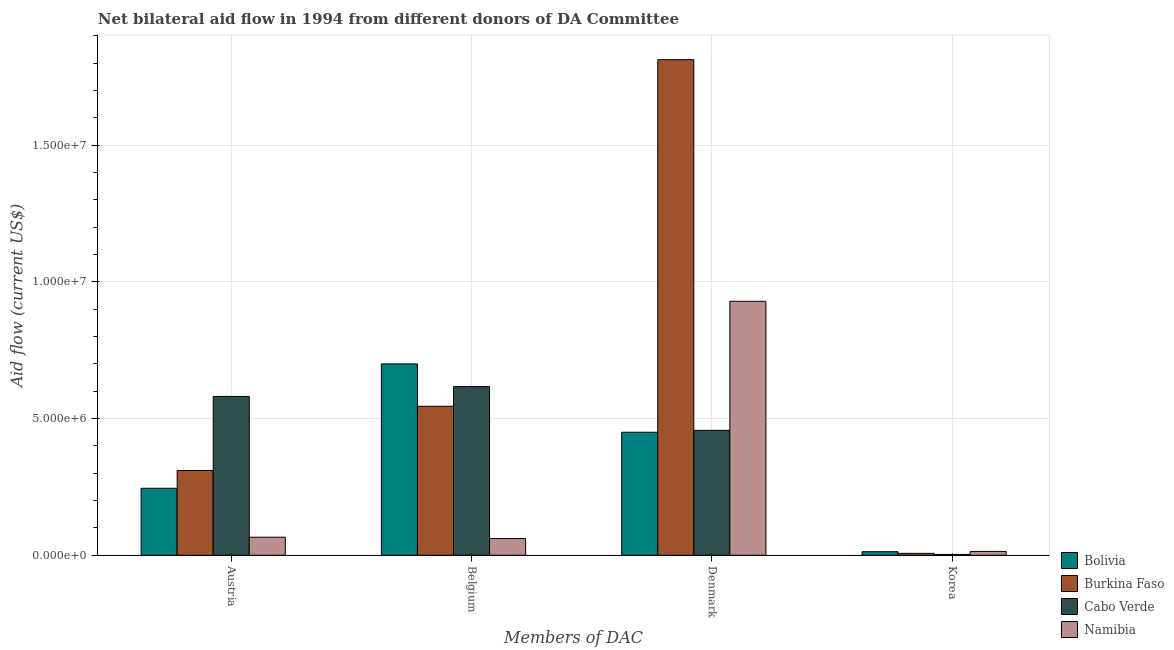How many groups of bars are there?
Provide a short and direct response. 4. Are the number of bars per tick equal to the number of legend labels?
Provide a short and direct response. Yes. How many bars are there on the 2nd tick from the left?
Your answer should be very brief. 4. How many bars are there on the 2nd tick from the right?
Offer a very short reply. 4. What is the label of the 2nd group of bars from the left?
Your answer should be very brief. Belgium. What is the amount of aid given by denmark in Bolivia?
Make the answer very short. 4.50e+06. Across all countries, what is the maximum amount of aid given by denmark?
Ensure brevity in your answer.  1.81e+07. Across all countries, what is the minimum amount of aid given by austria?
Offer a very short reply. 6.60e+05. In which country was the amount of aid given by korea maximum?
Provide a short and direct response. Namibia. In which country was the amount of aid given by austria minimum?
Offer a terse response. Namibia. What is the total amount of aid given by denmark in the graph?
Your answer should be compact. 3.65e+07. What is the difference between the amount of aid given by belgium in Bolivia and that in Burkina Faso?
Make the answer very short. 1.55e+06. What is the difference between the amount of aid given by korea in Cabo Verde and the amount of aid given by austria in Burkina Faso?
Your response must be concise. -3.07e+06. What is the average amount of aid given by belgium per country?
Your answer should be compact. 4.81e+06. What is the difference between the amount of aid given by austria and amount of aid given by korea in Burkina Faso?
Your answer should be very brief. 3.03e+06. In how many countries, is the amount of aid given by belgium greater than 8000000 US$?
Ensure brevity in your answer.  0. What is the ratio of the amount of aid given by denmark in Namibia to that in Bolivia?
Your answer should be compact. 2.06. What is the difference between the highest and the lowest amount of aid given by denmark?
Ensure brevity in your answer.  1.36e+07. In how many countries, is the amount of aid given by austria greater than the average amount of aid given by austria taken over all countries?
Your response must be concise. 2. Is the sum of the amount of aid given by korea in Burkina Faso and Cabo Verde greater than the maximum amount of aid given by denmark across all countries?
Give a very brief answer. No. What does the 2nd bar from the left in Denmark represents?
Provide a short and direct response. Burkina Faso. What does the 1st bar from the right in Austria represents?
Your answer should be compact. Namibia. How many bars are there?
Offer a very short reply. 16. What is the difference between two consecutive major ticks on the Y-axis?
Ensure brevity in your answer.  5.00e+06. Are the values on the major ticks of Y-axis written in scientific E-notation?
Give a very brief answer. Yes. Does the graph contain any zero values?
Offer a terse response. No. Where does the legend appear in the graph?
Ensure brevity in your answer.  Bottom right. How many legend labels are there?
Provide a short and direct response. 4. How are the legend labels stacked?
Your response must be concise. Vertical. What is the title of the graph?
Your response must be concise. Net bilateral aid flow in 1994 from different donors of DA Committee. Does "Turkmenistan" appear as one of the legend labels in the graph?
Make the answer very short. No. What is the label or title of the X-axis?
Provide a succinct answer. Members of DAC. What is the Aid flow (current US$) of Bolivia in Austria?
Provide a short and direct response. 2.45e+06. What is the Aid flow (current US$) of Burkina Faso in Austria?
Ensure brevity in your answer.  3.10e+06. What is the Aid flow (current US$) of Cabo Verde in Austria?
Your answer should be very brief. 5.81e+06. What is the Aid flow (current US$) in Bolivia in Belgium?
Offer a very short reply. 7.00e+06. What is the Aid flow (current US$) of Burkina Faso in Belgium?
Provide a succinct answer. 5.45e+06. What is the Aid flow (current US$) of Cabo Verde in Belgium?
Ensure brevity in your answer.  6.17e+06. What is the Aid flow (current US$) in Namibia in Belgium?
Your answer should be very brief. 6.10e+05. What is the Aid flow (current US$) in Bolivia in Denmark?
Keep it short and to the point. 4.50e+06. What is the Aid flow (current US$) in Burkina Faso in Denmark?
Provide a short and direct response. 1.81e+07. What is the Aid flow (current US$) of Cabo Verde in Denmark?
Ensure brevity in your answer.  4.57e+06. What is the Aid flow (current US$) in Namibia in Denmark?
Give a very brief answer. 9.29e+06. What is the Aid flow (current US$) of Bolivia in Korea?
Provide a short and direct response. 1.30e+05. What is the Aid flow (current US$) in Cabo Verde in Korea?
Your answer should be compact. 3.00e+04. Across all Members of DAC, what is the maximum Aid flow (current US$) of Burkina Faso?
Your response must be concise. 1.81e+07. Across all Members of DAC, what is the maximum Aid flow (current US$) of Cabo Verde?
Your answer should be compact. 6.17e+06. Across all Members of DAC, what is the maximum Aid flow (current US$) in Namibia?
Make the answer very short. 9.29e+06. Across all Members of DAC, what is the minimum Aid flow (current US$) of Bolivia?
Your answer should be compact. 1.30e+05. Across all Members of DAC, what is the minimum Aid flow (current US$) in Burkina Faso?
Your response must be concise. 7.00e+04. Across all Members of DAC, what is the minimum Aid flow (current US$) in Cabo Verde?
Provide a short and direct response. 3.00e+04. What is the total Aid flow (current US$) of Bolivia in the graph?
Your response must be concise. 1.41e+07. What is the total Aid flow (current US$) of Burkina Faso in the graph?
Provide a short and direct response. 2.68e+07. What is the total Aid flow (current US$) of Cabo Verde in the graph?
Your answer should be very brief. 1.66e+07. What is the total Aid flow (current US$) in Namibia in the graph?
Your answer should be very brief. 1.07e+07. What is the difference between the Aid flow (current US$) in Bolivia in Austria and that in Belgium?
Ensure brevity in your answer.  -4.55e+06. What is the difference between the Aid flow (current US$) in Burkina Faso in Austria and that in Belgium?
Provide a short and direct response. -2.35e+06. What is the difference between the Aid flow (current US$) in Cabo Verde in Austria and that in Belgium?
Ensure brevity in your answer.  -3.60e+05. What is the difference between the Aid flow (current US$) of Bolivia in Austria and that in Denmark?
Provide a succinct answer. -2.05e+06. What is the difference between the Aid flow (current US$) of Burkina Faso in Austria and that in Denmark?
Your response must be concise. -1.50e+07. What is the difference between the Aid flow (current US$) in Cabo Verde in Austria and that in Denmark?
Offer a very short reply. 1.24e+06. What is the difference between the Aid flow (current US$) in Namibia in Austria and that in Denmark?
Give a very brief answer. -8.63e+06. What is the difference between the Aid flow (current US$) of Bolivia in Austria and that in Korea?
Your answer should be very brief. 2.32e+06. What is the difference between the Aid flow (current US$) in Burkina Faso in Austria and that in Korea?
Your answer should be compact. 3.03e+06. What is the difference between the Aid flow (current US$) in Cabo Verde in Austria and that in Korea?
Ensure brevity in your answer.  5.78e+06. What is the difference between the Aid flow (current US$) of Namibia in Austria and that in Korea?
Provide a succinct answer. 5.20e+05. What is the difference between the Aid flow (current US$) of Bolivia in Belgium and that in Denmark?
Give a very brief answer. 2.50e+06. What is the difference between the Aid flow (current US$) in Burkina Faso in Belgium and that in Denmark?
Offer a very short reply. -1.27e+07. What is the difference between the Aid flow (current US$) of Cabo Verde in Belgium and that in Denmark?
Your answer should be compact. 1.60e+06. What is the difference between the Aid flow (current US$) in Namibia in Belgium and that in Denmark?
Give a very brief answer. -8.68e+06. What is the difference between the Aid flow (current US$) of Bolivia in Belgium and that in Korea?
Your answer should be compact. 6.87e+06. What is the difference between the Aid flow (current US$) in Burkina Faso in Belgium and that in Korea?
Your answer should be very brief. 5.38e+06. What is the difference between the Aid flow (current US$) in Cabo Verde in Belgium and that in Korea?
Your response must be concise. 6.14e+06. What is the difference between the Aid flow (current US$) of Bolivia in Denmark and that in Korea?
Your answer should be very brief. 4.37e+06. What is the difference between the Aid flow (current US$) in Burkina Faso in Denmark and that in Korea?
Ensure brevity in your answer.  1.81e+07. What is the difference between the Aid flow (current US$) of Cabo Verde in Denmark and that in Korea?
Offer a very short reply. 4.54e+06. What is the difference between the Aid flow (current US$) of Namibia in Denmark and that in Korea?
Provide a succinct answer. 9.15e+06. What is the difference between the Aid flow (current US$) in Bolivia in Austria and the Aid flow (current US$) in Cabo Verde in Belgium?
Provide a succinct answer. -3.72e+06. What is the difference between the Aid flow (current US$) of Bolivia in Austria and the Aid flow (current US$) of Namibia in Belgium?
Your answer should be very brief. 1.84e+06. What is the difference between the Aid flow (current US$) of Burkina Faso in Austria and the Aid flow (current US$) of Cabo Verde in Belgium?
Your answer should be very brief. -3.07e+06. What is the difference between the Aid flow (current US$) of Burkina Faso in Austria and the Aid flow (current US$) of Namibia in Belgium?
Make the answer very short. 2.49e+06. What is the difference between the Aid flow (current US$) in Cabo Verde in Austria and the Aid flow (current US$) in Namibia in Belgium?
Make the answer very short. 5.20e+06. What is the difference between the Aid flow (current US$) of Bolivia in Austria and the Aid flow (current US$) of Burkina Faso in Denmark?
Offer a very short reply. -1.57e+07. What is the difference between the Aid flow (current US$) in Bolivia in Austria and the Aid flow (current US$) in Cabo Verde in Denmark?
Provide a succinct answer. -2.12e+06. What is the difference between the Aid flow (current US$) in Bolivia in Austria and the Aid flow (current US$) in Namibia in Denmark?
Make the answer very short. -6.84e+06. What is the difference between the Aid flow (current US$) of Burkina Faso in Austria and the Aid flow (current US$) of Cabo Verde in Denmark?
Provide a short and direct response. -1.47e+06. What is the difference between the Aid flow (current US$) in Burkina Faso in Austria and the Aid flow (current US$) in Namibia in Denmark?
Offer a very short reply. -6.19e+06. What is the difference between the Aid flow (current US$) of Cabo Verde in Austria and the Aid flow (current US$) of Namibia in Denmark?
Offer a terse response. -3.48e+06. What is the difference between the Aid flow (current US$) in Bolivia in Austria and the Aid flow (current US$) in Burkina Faso in Korea?
Provide a short and direct response. 2.38e+06. What is the difference between the Aid flow (current US$) of Bolivia in Austria and the Aid flow (current US$) of Cabo Verde in Korea?
Provide a short and direct response. 2.42e+06. What is the difference between the Aid flow (current US$) of Bolivia in Austria and the Aid flow (current US$) of Namibia in Korea?
Keep it short and to the point. 2.31e+06. What is the difference between the Aid flow (current US$) of Burkina Faso in Austria and the Aid flow (current US$) of Cabo Verde in Korea?
Provide a short and direct response. 3.07e+06. What is the difference between the Aid flow (current US$) of Burkina Faso in Austria and the Aid flow (current US$) of Namibia in Korea?
Your answer should be very brief. 2.96e+06. What is the difference between the Aid flow (current US$) in Cabo Verde in Austria and the Aid flow (current US$) in Namibia in Korea?
Your response must be concise. 5.67e+06. What is the difference between the Aid flow (current US$) in Bolivia in Belgium and the Aid flow (current US$) in Burkina Faso in Denmark?
Keep it short and to the point. -1.11e+07. What is the difference between the Aid flow (current US$) of Bolivia in Belgium and the Aid flow (current US$) of Cabo Verde in Denmark?
Provide a succinct answer. 2.43e+06. What is the difference between the Aid flow (current US$) in Bolivia in Belgium and the Aid flow (current US$) in Namibia in Denmark?
Make the answer very short. -2.29e+06. What is the difference between the Aid flow (current US$) of Burkina Faso in Belgium and the Aid flow (current US$) of Cabo Verde in Denmark?
Keep it short and to the point. 8.80e+05. What is the difference between the Aid flow (current US$) in Burkina Faso in Belgium and the Aid flow (current US$) in Namibia in Denmark?
Offer a terse response. -3.84e+06. What is the difference between the Aid flow (current US$) in Cabo Verde in Belgium and the Aid flow (current US$) in Namibia in Denmark?
Your response must be concise. -3.12e+06. What is the difference between the Aid flow (current US$) of Bolivia in Belgium and the Aid flow (current US$) of Burkina Faso in Korea?
Give a very brief answer. 6.93e+06. What is the difference between the Aid flow (current US$) in Bolivia in Belgium and the Aid flow (current US$) in Cabo Verde in Korea?
Provide a short and direct response. 6.97e+06. What is the difference between the Aid flow (current US$) of Bolivia in Belgium and the Aid flow (current US$) of Namibia in Korea?
Provide a succinct answer. 6.86e+06. What is the difference between the Aid flow (current US$) of Burkina Faso in Belgium and the Aid flow (current US$) of Cabo Verde in Korea?
Your answer should be compact. 5.42e+06. What is the difference between the Aid flow (current US$) of Burkina Faso in Belgium and the Aid flow (current US$) of Namibia in Korea?
Your answer should be compact. 5.31e+06. What is the difference between the Aid flow (current US$) in Cabo Verde in Belgium and the Aid flow (current US$) in Namibia in Korea?
Offer a terse response. 6.03e+06. What is the difference between the Aid flow (current US$) of Bolivia in Denmark and the Aid flow (current US$) of Burkina Faso in Korea?
Your answer should be compact. 4.43e+06. What is the difference between the Aid flow (current US$) of Bolivia in Denmark and the Aid flow (current US$) of Cabo Verde in Korea?
Give a very brief answer. 4.47e+06. What is the difference between the Aid flow (current US$) in Bolivia in Denmark and the Aid flow (current US$) in Namibia in Korea?
Offer a terse response. 4.36e+06. What is the difference between the Aid flow (current US$) in Burkina Faso in Denmark and the Aid flow (current US$) in Cabo Verde in Korea?
Keep it short and to the point. 1.81e+07. What is the difference between the Aid flow (current US$) in Burkina Faso in Denmark and the Aid flow (current US$) in Namibia in Korea?
Keep it short and to the point. 1.80e+07. What is the difference between the Aid flow (current US$) of Cabo Verde in Denmark and the Aid flow (current US$) of Namibia in Korea?
Your answer should be compact. 4.43e+06. What is the average Aid flow (current US$) in Bolivia per Members of DAC?
Provide a short and direct response. 3.52e+06. What is the average Aid flow (current US$) in Burkina Faso per Members of DAC?
Give a very brief answer. 6.69e+06. What is the average Aid flow (current US$) in Cabo Verde per Members of DAC?
Give a very brief answer. 4.14e+06. What is the average Aid flow (current US$) in Namibia per Members of DAC?
Ensure brevity in your answer.  2.68e+06. What is the difference between the Aid flow (current US$) in Bolivia and Aid flow (current US$) in Burkina Faso in Austria?
Give a very brief answer. -6.50e+05. What is the difference between the Aid flow (current US$) in Bolivia and Aid flow (current US$) in Cabo Verde in Austria?
Your response must be concise. -3.36e+06. What is the difference between the Aid flow (current US$) in Bolivia and Aid flow (current US$) in Namibia in Austria?
Ensure brevity in your answer.  1.79e+06. What is the difference between the Aid flow (current US$) of Burkina Faso and Aid flow (current US$) of Cabo Verde in Austria?
Give a very brief answer. -2.71e+06. What is the difference between the Aid flow (current US$) of Burkina Faso and Aid flow (current US$) of Namibia in Austria?
Give a very brief answer. 2.44e+06. What is the difference between the Aid flow (current US$) in Cabo Verde and Aid flow (current US$) in Namibia in Austria?
Give a very brief answer. 5.15e+06. What is the difference between the Aid flow (current US$) in Bolivia and Aid flow (current US$) in Burkina Faso in Belgium?
Offer a terse response. 1.55e+06. What is the difference between the Aid flow (current US$) in Bolivia and Aid flow (current US$) in Cabo Verde in Belgium?
Your answer should be very brief. 8.30e+05. What is the difference between the Aid flow (current US$) in Bolivia and Aid flow (current US$) in Namibia in Belgium?
Provide a succinct answer. 6.39e+06. What is the difference between the Aid flow (current US$) of Burkina Faso and Aid flow (current US$) of Cabo Verde in Belgium?
Your answer should be compact. -7.20e+05. What is the difference between the Aid flow (current US$) of Burkina Faso and Aid flow (current US$) of Namibia in Belgium?
Your answer should be compact. 4.84e+06. What is the difference between the Aid flow (current US$) of Cabo Verde and Aid flow (current US$) of Namibia in Belgium?
Ensure brevity in your answer.  5.56e+06. What is the difference between the Aid flow (current US$) of Bolivia and Aid flow (current US$) of Burkina Faso in Denmark?
Your answer should be compact. -1.36e+07. What is the difference between the Aid flow (current US$) in Bolivia and Aid flow (current US$) in Namibia in Denmark?
Make the answer very short. -4.79e+06. What is the difference between the Aid flow (current US$) of Burkina Faso and Aid flow (current US$) of Cabo Verde in Denmark?
Make the answer very short. 1.36e+07. What is the difference between the Aid flow (current US$) in Burkina Faso and Aid flow (current US$) in Namibia in Denmark?
Give a very brief answer. 8.84e+06. What is the difference between the Aid flow (current US$) of Cabo Verde and Aid flow (current US$) of Namibia in Denmark?
Your answer should be very brief. -4.72e+06. What is the difference between the Aid flow (current US$) of Bolivia and Aid flow (current US$) of Cabo Verde in Korea?
Give a very brief answer. 1.00e+05. What is the difference between the Aid flow (current US$) of Bolivia and Aid flow (current US$) of Namibia in Korea?
Keep it short and to the point. -10000. What is the difference between the Aid flow (current US$) in Burkina Faso and Aid flow (current US$) in Cabo Verde in Korea?
Your response must be concise. 4.00e+04. What is the ratio of the Aid flow (current US$) of Burkina Faso in Austria to that in Belgium?
Give a very brief answer. 0.57. What is the ratio of the Aid flow (current US$) of Cabo Verde in Austria to that in Belgium?
Your answer should be compact. 0.94. What is the ratio of the Aid flow (current US$) in Namibia in Austria to that in Belgium?
Offer a very short reply. 1.08. What is the ratio of the Aid flow (current US$) in Bolivia in Austria to that in Denmark?
Make the answer very short. 0.54. What is the ratio of the Aid flow (current US$) of Burkina Faso in Austria to that in Denmark?
Offer a very short reply. 0.17. What is the ratio of the Aid flow (current US$) in Cabo Verde in Austria to that in Denmark?
Provide a short and direct response. 1.27. What is the ratio of the Aid flow (current US$) of Namibia in Austria to that in Denmark?
Provide a short and direct response. 0.07. What is the ratio of the Aid flow (current US$) of Bolivia in Austria to that in Korea?
Your response must be concise. 18.85. What is the ratio of the Aid flow (current US$) in Burkina Faso in Austria to that in Korea?
Ensure brevity in your answer.  44.29. What is the ratio of the Aid flow (current US$) in Cabo Verde in Austria to that in Korea?
Offer a very short reply. 193.67. What is the ratio of the Aid flow (current US$) in Namibia in Austria to that in Korea?
Offer a very short reply. 4.71. What is the ratio of the Aid flow (current US$) in Bolivia in Belgium to that in Denmark?
Your answer should be compact. 1.56. What is the ratio of the Aid flow (current US$) in Burkina Faso in Belgium to that in Denmark?
Ensure brevity in your answer.  0.3. What is the ratio of the Aid flow (current US$) of Cabo Verde in Belgium to that in Denmark?
Offer a terse response. 1.35. What is the ratio of the Aid flow (current US$) of Namibia in Belgium to that in Denmark?
Your answer should be very brief. 0.07. What is the ratio of the Aid flow (current US$) of Bolivia in Belgium to that in Korea?
Ensure brevity in your answer.  53.85. What is the ratio of the Aid flow (current US$) in Burkina Faso in Belgium to that in Korea?
Provide a short and direct response. 77.86. What is the ratio of the Aid flow (current US$) of Cabo Verde in Belgium to that in Korea?
Offer a terse response. 205.67. What is the ratio of the Aid flow (current US$) of Namibia in Belgium to that in Korea?
Give a very brief answer. 4.36. What is the ratio of the Aid flow (current US$) of Bolivia in Denmark to that in Korea?
Offer a very short reply. 34.62. What is the ratio of the Aid flow (current US$) in Burkina Faso in Denmark to that in Korea?
Ensure brevity in your answer.  259. What is the ratio of the Aid flow (current US$) in Cabo Verde in Denmark to that in Korea?
Offer a very short reply. 152.33. What is the ratio of the Aid flow (current US$) of Namibia in Denmark to that in Korea?
Provide a short and direct response. 66.36. What is the difference between the highest and the second highest Aid flow (current US$) of Bolivia?
Offer a terse response. 2.50e+06. What is the difference between the highest and the second highest Aid flow (current US$) in Burkina Faso?
Your answer should be very brief. 1.27e+07. What is the difference between the highest and the second highest Aid flow (current US$) in Cabo Verde?
Ensure brevity in your answer.  3.60e+05. What is the difference between the highest and the second highest Aid flow (current US$) in Namibia?
Keep it short and to the point. 8.63e+06. What is the difference between the highest and the lowest Aid flow (current US$) in Bolivia?
Your answer should be very brief. 6.87e+06. What is the difference between the highest and the lowest Aid flow (current US$) of Burkina Faso?
Your response must be concise. 1.81e+07. What is the difference between the highest and the lowest Aid flow (current US$) in Cabo Verde?
Offer a terse response. 6.14e+06. What is the difference between the highest and the lowest Aid flow (current US$) in Namibia?
Keep it short and to the point. 9.15e+06. 